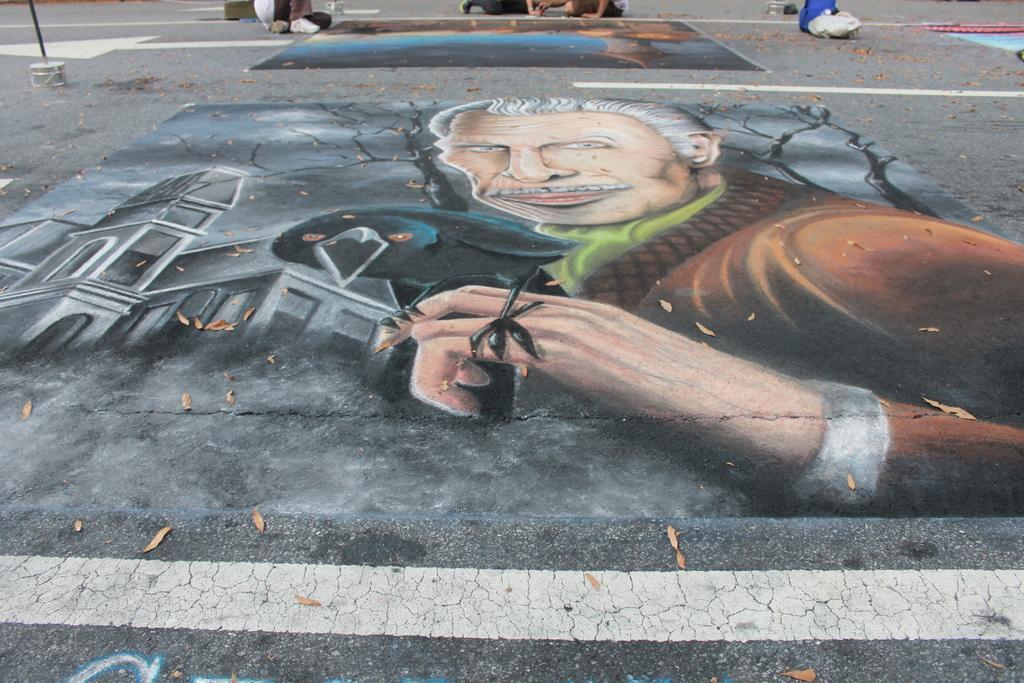Describe this image in one or two sentences. In this image, we can see paintings on the road and in the background, there are some people and there is a bucket and a brush. 